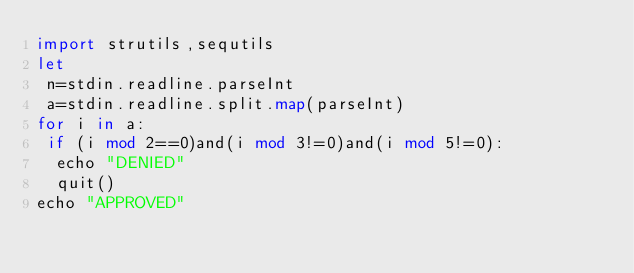Convert code to text. <code><loc_0><loc_0><loc_500><loc_500><_Nim_>import strutils,sequtils
let
 n=stdin.readline.parseInt
 a=stdin.readline.split.map(parseInt)
for i in a:
 if (i mod 2==0)and(i mod 3!=0)and(i mod 5!=0):
  echo "DENIED"
  quit()
echo "APPROVED"</code> 